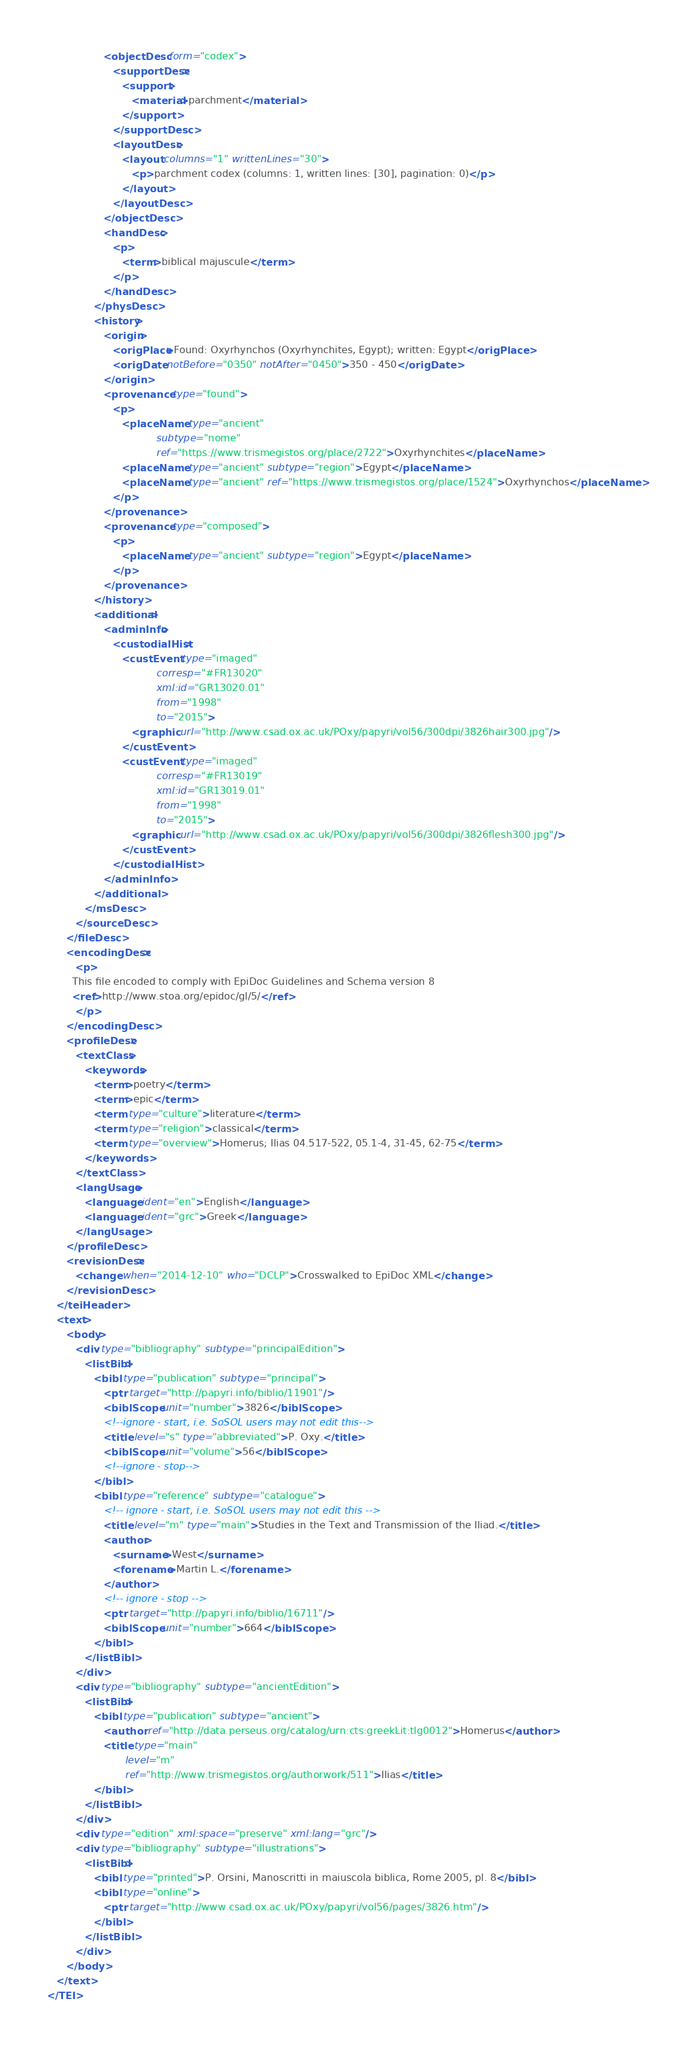Convert code to text. <code><loc_0><loc_0><loc_500><loc_500><_XML_>                  <objectDesc form="codex">
                     <supportDesc>
                        <support>
                           <material>parchment</material>
                        </support>
                     </supportDesc>
                     <layoutDesc>
                        <layout columns="1" writtenLines="30">
                           <p>parchment codex (columns: 1, written lines: [30], pagination: 0)</p>
                        </layout>
                     </layoutDesc>
                  </objectDesc>
                  <handDesc>
                     <p>
                        <term>biblical majuscule</term>
                     </p>
                  </handDesc>
               </physDesc>
               <history>
                  <origin>
                     <origPlace>Found: Oxyrhynchos (Oxyrhynchites, Egypt); written: Egypt</origPlace>
                     <origDate notBefore="0350" notAfter="0450">350 - 450</origDate>
                  </origin>
                  <provenance type="found">
                     <p>
                        <placeName type="ancient"
                                   subtype="nome"
                                   ref="https://www.trismegistos.org/place/2722">Oxyrhynchites</placeName>
                        <placeName type="ancient" subtype="region">Egypt</placeName>
                        <placeName type="ancient" ref="https://www.trismegistos.org/place/1524">Oxyrhynchos</placeName>
                     </p>
                  </provenance>
                  <provenance type="composed">
                     <p>
                        <placeName type="ancient" subtype="region">Egypt</placeName>
                     </p>
                  </provenance>
               </history>
               <additional>
                  <adminInfo>
                     <custodialHist>
                        <custEvent type="imaged"
                                   corresp="#FR13020"
                                   xml:id="GR13020.01"
                                   from="1998"
                                   to="2015">
                           <graphic url="http://www.csad.ox.ac.uk/POxy/papyri/vol56/300dpi/3826hair300.jpg"/>
                        </custEvent>
                        <custEvent type="imaged"
                                   corresp="#FR13019"
                                   xml:id="GR13019.01"
                                   from="1998"
                                   to="2015">
                           <graphic url="http://www.csad.ox.ac.uk/POxy/papyri/vol56/300dpi/3826flesh300.jpg"/>
                        </custEvent>
                     </custodialHist>
                  </adminInfo>
               </additional>
            </msDesc>
         </sourceDesc>
      </fileDesc>
      <encodingDesc>
         <p>
        This file encoded to comply with EpiDoc Guidelines and Schema version 8
        <ref>http://www.stoa.org/epidoc/gl/5/</ref>
         </p>
      </encodingDesc>
      <profileDesc>
         <textClass>
            <keywords>
               <term>poetry</term>
               <term>epic</term>
               <term type="culture">literature</term>
               <term type="religion">classical</term>
               <term type="overview">Homerus; Ilias 04.517-522, 05.1-4, 31-45, 62-75</term>
            </keywords>
         </textClass>
         <langUsage>
            <language ident="en">English</language>
            <language ident="grc">Greek</language>
         </langUsage>
      </profileDesc>
      <revisionDesc>
         <change when="2014-12-10" who="DCLP">Crosswalked to EpiDoc XML</change>
      </revisionDesc>
   </teiHeader>
   <text>
      <body>
         <div type="bibliography" subtype="principalEdition">
            <listBibl>
               <bibl type="publication" subtype="principal">
                  <ptr target="http://papyri.info/biblio/11901"/>
                  <biblScope unit="number">3826</biblScope>
                  <!--ignore - start, i.e. SoSOL users may not edit this-->
                  <title level="s" type="abbreviated">P. Oxy.</title>
                  <biblScope unit="volume">56</biblScope>
                  <!--ignore - stop-->
               </bibl>
               <bibl type="reference" subtype="catalogue">
                  <!-- ignore - start, i.e. SoSOL users may not edit this -->
                  <title level="m" type="main">Studies in the Text and Transmission of the Iliad.</title>
                  <author>
                     <surname>West</surname>
                     <forename>Martin L.</forename>
                  </author>
                  <!-- ignore - stop -->
                  <ptr target="http://papyri.info/biblio/16711"/>
                  <biblScope unit="number">664</biblScope>
               </bibl>
            </listBibl>
         </div>
         <div type="bibliography" subtype="ancientEdition">
            <listBibl>
               <bibl type="publication" subtype="ancient">
                  <author ref="http://data.perseus.org/catalog/urn:cts:greekLit:tlg0012">Homerus</author>
                  <title type="main"
                         level="m"
                         ref="http://www.trismegistos.org/authorwork/511">Ilias</title>
               </bibl>
            </listBibl>
         </div>
         <div type="edition" xml:space="preserve" xml:lang="grc"/>
         <div type="bibliography" subtype="illustrations">
            <listBibl>
               <bibl type="printed">P. Orsini, Manoscritti in maiuscola biblica, Rome 2005, pl. 8</bibl>
               <bibl type="online">
                  <ptr target="http://www.csad.ox.ac.uk/POxy/papyri/vol56/pages/3826.htm"/>
               </bibl>
            </listBibl>
         </div>
      </body>
   </text>
</TEI>
</code> 